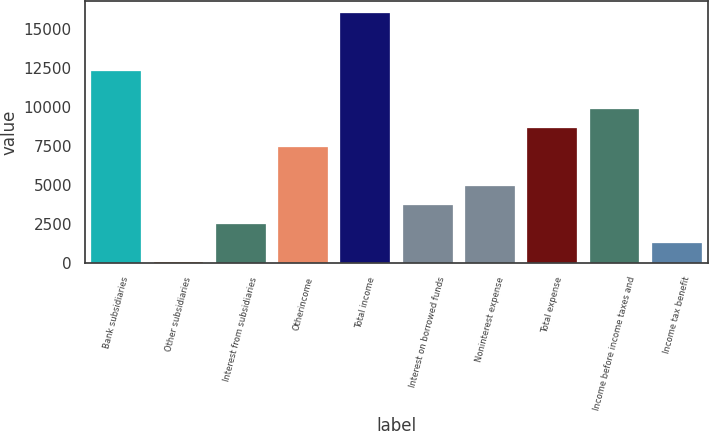Convert chart. <chart><loc_0><loc_0><loc_500><loc_500><bar_chart><fcel>Bank subsidiaries<fcel>Other subsidiaries<fcel>Interest from subsidiaries<fcel>Otherincome<fcel>Total income<fcel>Interest on borrowed funds<fcel>Noninterest expense<fcel>Total expense<fcel>Income before income taxes and<fcel>Income tax benefit<nl><fcel>12311<fcel>34<fcel>2489.4<fcel>7400.2<fcel>15994.1<fcel>3717.1<fcel>4944.8<fcel>8627.9<fcel>9855.6<fcel>1261.7<nl></chart> 